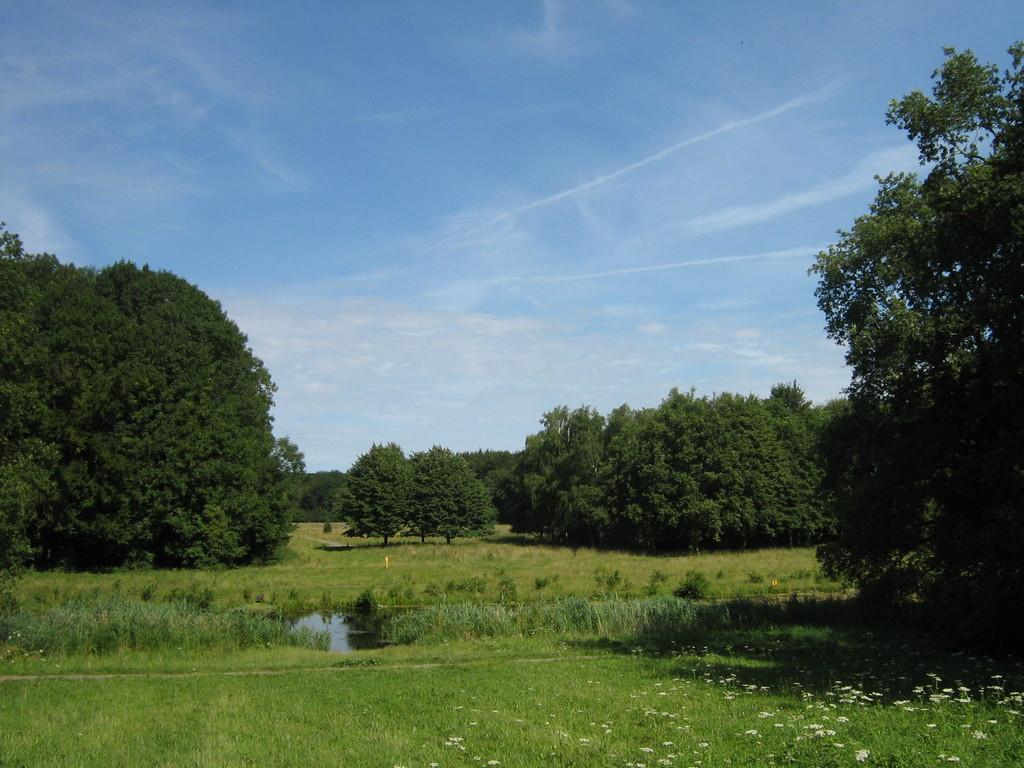What natural element can be seen in the image? Water is visible in the image. What type of vegetation is present in the image? There is grass and trees in the image. Are there any other flora elements in the image? Yes, there are flowers associated with plants in the image. How many owls can be seen in the image? There are no owls present in the image. What color are the eyes of the owl in the image? There is no owl in the image, so it is not possible to determine the color of its eyes. 